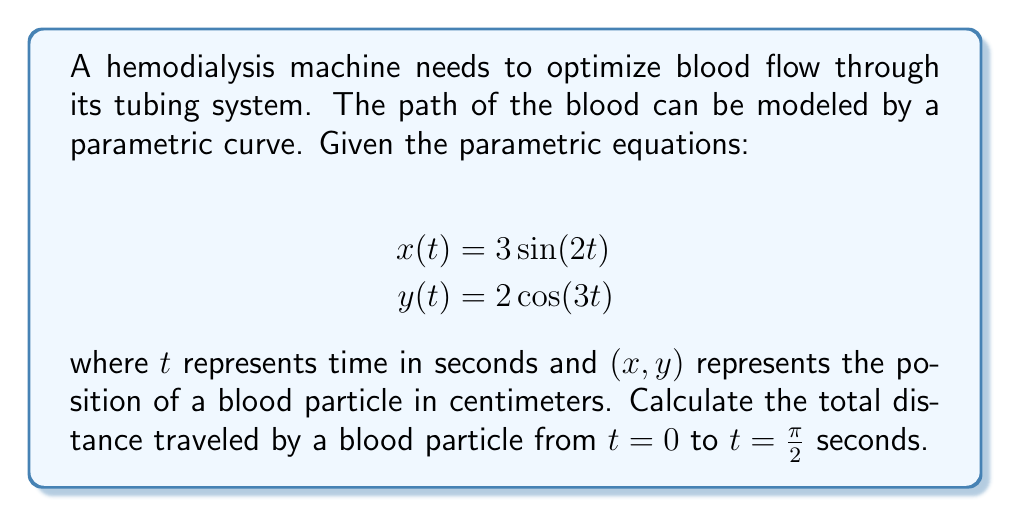What is the answer to this math problem? To solve this problem, we need to follow these steps:

1) The distance traveled along a parametric curve is given by the arc length formula:

   $$L = \int_{a}^{b} \sqrt{\left(\frac{dx}{dt}\right)^2 + \left(\frac{dy}{dt}\right)^2} dt$$

2) First, let's find $\frac{dx}{dt}$ and $\frac{dy}{dt}$:
   
   $\frac{dx}{dt} = 6\cos(2t)$
   $\frac{dy}{dt} = -6\sin(3t)$

3) Now, we can substitute these into our arc length formula:

   $$L = \int_{0}^{\frac{\pi}{2}} \sqrt{(6\cos(2t))^2 + (-6\sin(3t))^2} dt$$

4) Simplify under the square root:

   $$L = \int_{0}^{\frac{\pi}{2}} \sqrt{36\cos^2(2t) + 36\sin^2(3t)} dt$$

5) Factor out the common 36:

   $$L = 6\int_{0}^{\frac{\pi}{2}} \sqrt{\cos^2(2t) + \sin^2(3t)} dt$$

6) This integral cannot be solved analytically and requires numerical integration methods. Using a computational tool or numerical integration technique, we can approximate this integral.

7) The result of this numerical integration is approximately 9.84 cm.
Answer: The total distance traveled by a blood particle from $t=0$ to $t=\frac{\pi}{2}$ seconds is approximately 9.84 cm. 